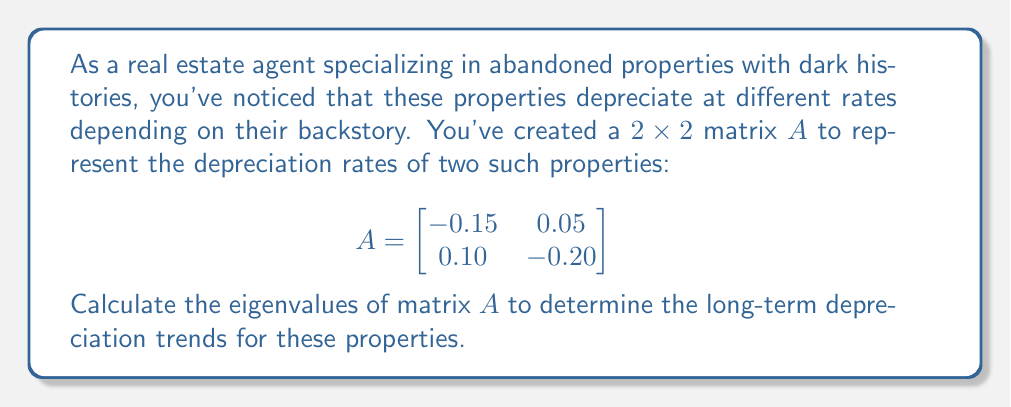Provide a solution to this math problem. To find the eigenvalues of matrix $A$, we follow these steps:

1) The characteristic equation is given by $det(A - \lambda I) = 0$, where $\lambda$ represents the eigenvalues and $I$ is the $2 \times 2$ identity matrix.

2) Expand the determinant:
   $$det\begin{bmatrix}
   -0.15 - \lambda & 0.05 \\
   0.10 & -0.20 - \lambda
   \end{bmatrix} = 0$$

3) Calculate the determinant:
   $$(-0.15 - \lambda)(-0.20 - \lambda) - (0.05)(0.10) = 0$$

4) Simplify:
   $$\lambda^2 + 0.35\lambda + 0.025 = 0$$

5) This is a quadratic equation. We can solve it using the quadratic formula:
   $$\lambda = \frac{-b \pm \sqrt{b^2 - 4ac}}{2a}$$
   where $a = 1$, $b = 0.35$, and $c = 0.025$

6) Substituting these values:
   $$\lambda = \frac{-0.35 \pm \sqrt{0.35^2 - 4(1)(0.025)}}{2(1)}$$

7) Simplify:
   $$\lambda = \frac{-0.35 \pm \sqrt{0.1225 - 0.1}}{2} = \frac{-0.35 \pm \sqrt{0.0225}}{2} = \frac{-0.35 \pm 0.15}{2}$$

8) Therefore, the two eigenvalues are:
   $$\lambda_1 = \frac{-0.35 + 0.15}{2} = -0.10$$
   $$\lambda_2 = \frac{-0.35 - 0.15}{2} = -0.25$$
Answer: $\lambda_1 = -0.10$, $\lambda_2 = -0.25$ 